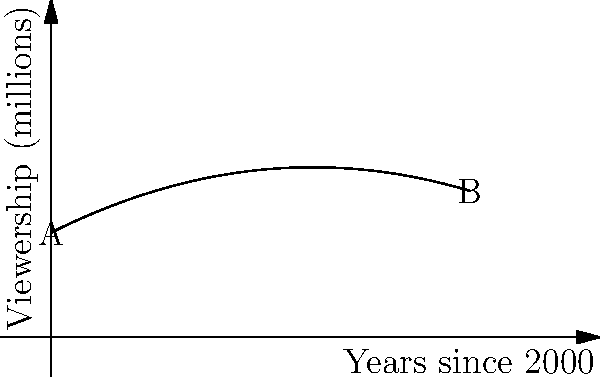The graph represents the viewership (in millions) of horse racing broadcasts from the year 2000 to 2020. If the function describing this curve is $f(x) = 5 + 0.5x - 0.02x^2$, where $x$ is the number of years since 2000, calculate the total viewership over this 20-year period. Round your answer to the nearest million viewers. To find the total viewership over the 20-year period, we need to calculate the area under the curve from $x=0$ to $x=20$. This can be done using a definite integral.

1) The integral we need to evaluate is:
   $$\int_0^{20} (5 + 0.5x - 0.02x^2) dx$$

2) Let's integrate term by term:
   $$\int_0^{20} 5 dx + \int_0^{20} 0.5x dx - \int_0^{20} 0.02x^2 dx$$

3) Evaluating each integral:
   $$[5x]_0^{20} + [0.25x^2]_0^{20} - [0.02\frac{x^3}{3}]_0^{20}$$

4) Substitute the limits:
   $$(5 \cdot 20) + (0.25 \cdot 20^2) - (0.02 \cdot \frac{20^3}{3}) - (0 + 0 - 0)$$

5) Simplify:
   $$100 + 100 - \frac{1600}{3} \approx 166.67$$

6) The result represents millions of viewers over 20 years.

7) Rounding to the nearest million: 167 million viewers.
Answer: 167 million viewers 